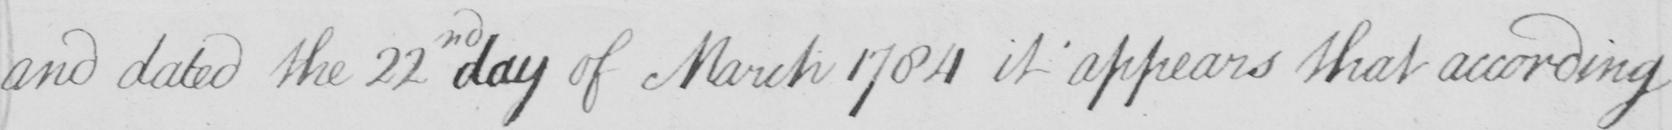Please transcribe the handwritten text in this image. and dated the 22nd day of March 1784 it appears that according 